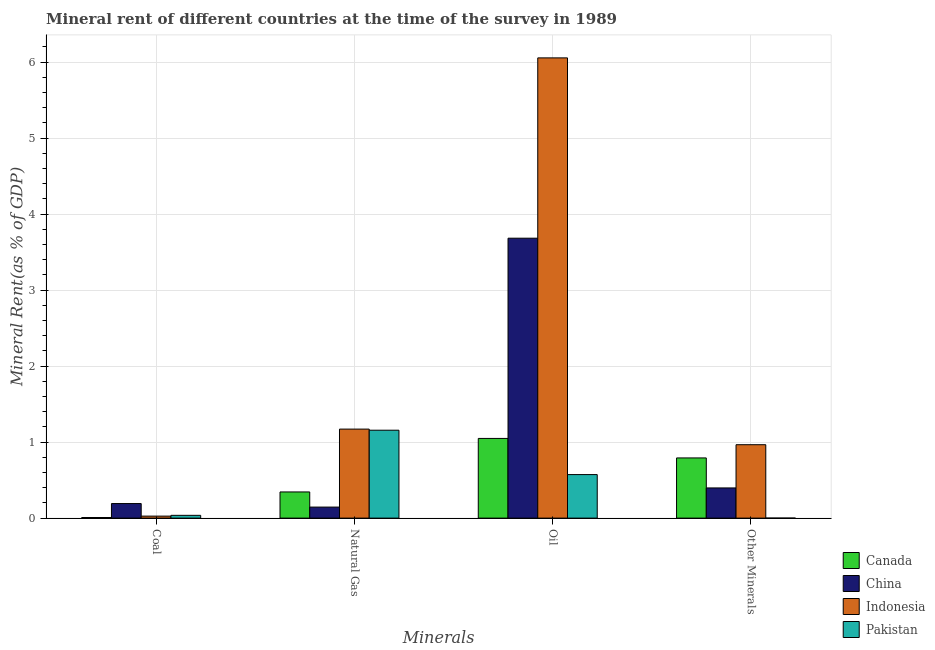How many different coloured bars are there?
Offer a very short reply. 4. Are the number of bars per tick equal to the number of legend labels?
Provide a short and direct response. Yes. Are the number of bars on each tick of the X-axis equal?
Offer a very short reply. Yes. How many bars are there on the 3rd tick from the right?
Offer a very short reply. 4. What is the label of the 3rd group of bars from the left?
Offer a very short reply. Oil. What is the  rent of other minerals in Canada?
Ensure brevity in your answer.  0.79. Across all countries, what is the maximum natural gas rent?
Your answer should be compact. 1.17. Across all countries, what is the minimum  rent of other minerals?
Your response must be concise. 0. In which country was the oil rent maximum?
Your response must be concise. Indonesia. What is the total  rent of other minerals in the graph?
Your response must be concise. 2.16. What is the difference between the natural gas rent in Indonesia and that in China?
Offer a terse response. 1.03. What is the difference between the oil rent in Pakistan and the coal rent in China?
Give a very brief answer. 0.38. What is the average natural gas rent per country?
Your answer should be compact. 0.7. What is the difference between the oil rent and coal rent in Canada?
Give a very brief answer. 1.04. What is the ratio of the coal rent in Indonesia to that in Pakistan?
Provide a short and direct response. 0.72. Is the difference between the coal rent in Pakistan and Indonesia greater than the difference between the  rent of other minerals in Pakistan and Indonesia?
Offer a terse response. Yes. What is the difference between the highest and the second highest oil rent?
Offer a very short reply. 2.37. What is the difference between the highest and the lowest coal rent?
Offer a terse response. 0.18. In how many countries, is the  rent of other minerals greater than the average  rent of other minerals taken over all countries?
Give a very brief answer. 2. Is the sum of the  rent of other minerals in Pakistan and Canada greater than the maximum natural gas rent across all countries?
Make the answer very short. No. Is it the case that in every country, the sum of the oil rent and coal rent is greater than the sum of natural gas rent and  rent of other minerals?
Give a very brief answer. No. What does the 1st bar from the left in Natural Gas represents?
Your answer should be compact. Canada. Is it the case that in every country, the sum of the coal rent and natural gas rent is greater than the oil rent?
Offer a very short reply. No. How many countries are there in the graph?
Offer a very short reply. 4. What is the difference between two consecutive major ticks on the Y-axis?
Offer a very short reply. 1. What is the title of the graph?
Provide a short and direct response. Mineral rent of different countries at the time of the survey in 1989. What is the label or title of the X-axis?
Your answer should be compact. Minerals. What is the label or title of the Y-axis?
Your answer should be very brief. Mineral Rent(as % of GDP). What is the Mineral Rent(as % of GDP) of Canada in Coal?
Your answer should be compact. 0.01. What is the Mineral Rent(as % of GDP) of China in Coal?
Make the answer very short. 0.19. What is the Mineral Rent(as % of GDP) in Indonesia in Coal?
Provide a succinct answer. 0.03. What is the Mineral Rent(as % of GDP) of Pakistan in Coal?
Offer a very short reply. 0.04. What is the Mineral Rent(as % of GDP) of Canada in Natural Gas?
Offer a very short reply. 0.34. What is the Mineral Rent(as % of GDP) in China in Natural Gas?
Keep it short and to the point. 0.15. What is the Mineral Rent(as % of GDP) in Indonesia in Natural Gas?
Ensure brevity in your answer.  1.17. What is the Mineral Rent(as % of GDP) of Pakistan in Natural Gas?
Your response must be concise. 1.16. What is the Mineral Rent(as % of GDP) in Canada in Oil?
Give a very brief answer. 1.05. What is the Mineral Rent(as % of GDP) in China in Oil?
Ensure brevity in your answer.  3.68. What is the Mineral Rent(as % of GDP) in Indonesia in Oil?
Your answer should be compact. 6.06. What is the Mineral Rent(as % of GDP) in Pakistan in Oil?
Keep it short and to the point. 0.57. What is the Mineral Rent(as % of GDP) of Canada in Other Minerals?
Provide a short and direct response. 0.79. What is the Mineral Rent(as % of GDP) of China in Other Minerals?
Give a very brief answer. 0.4. What is the Mineral Rent(as % of GDP) in Indonesia in Other Minerals?
Offer a terse response. 0.97. What is the Mineral Rent(as % of GDP) of Pakistan in Other Minerals?
Offer a very short reply. 0. Across all Minerals, what is the maximum Mineral Rent(as % of GDP) in Canada?
Keep it short and to the point. 1.05. Across all Minerals, what is the maximum Mineral Rent(as % of GDP) of China?
Keep it short and to the point. 3.68. Across all Minerals, what is the maximum Mineral Rent(as % of GDP) in Indonesia?
Make the answer very short. 6.06. Across all Minerals, what is the maximum Mineral Rent(as % of GDP) in Pakistan?
Your answer should be very brief. 1.16. Across all Minerals, what is the minimum Mineral Rent(as % of GDP) in Canada?
Ensure brevity in your answer.  0.01. Across all Minerals, what is the minimum Mineral Rent(as % of GDP) of China?
Provide a succinct answer. 0.15. Across all Minerals, what is the minimum Mineral Rent(as % of GDP) in Indonesia?
Provide a short and direct response. 0.03. Across all Minerals, what is the minimum Mineral Rent(as % of GDP) of Pakistan?
Ensure brevity in your answer.  0. What is the total Mineral Rent(as % of GDP) of Canada in the graph?
Provide a succinct answer. 2.19. What is the total Mineral Rent(as % of GDP) in China in the graph?
Offer a terse response. 4.42. What is the total Mineral Rent(as % of GDP) of Indonesia in the graph?
Your response must be concise. 8.22. What is the total Mineral Rent(as % of GDP) of Pakistan in the graph?
Keep it short and to the point. 1.77. What is the difference between the Mineral Rent(as % of GDP) of Canada in Coal and that in Natural Gas?
Provide a succinct answer. -0.34. What is the difference between the Mineral Rent(as % of GDP) of China in Coal and that in Natural Gas?
Your response must be concise. 0.05. What is the difference between the Mineral Rent(as % of GDP) of Indonesia in Coal and that in Natural Gas?
Give a very brief answer. -1.14. What is the difference between the Mineral Rent(as % of GDP) of Pakistan in Coal and that in Natural Gas?
Give a very brief answer. -1.12. What is the difference between the Mineral Rent(as % of GDP) of Canada in Coal and that in Oil?
Ensure brevity in your answer.  -1.04. What is the difference between the Mineral Rent(as % of GDP) of China in Coal and that in Oil?
Your answer should be compact. -3.49. What is the difference between the Mineral Rent(as % of GDP) in Indonesia in Coal and that in Oil?
Offer a terse response. -6.03. What is the difference between the Mineral Rent(as % of GDP) in Pakistan in Coal and that in Oil?
Provide a succinct answer. -0.54. What is the difference between the Mineral Rent(as % of GDP) of Canada in Coal and that in Other Minerals?
Offer a very short reply. -0.78. What is the difference between the Mineral Rent(as % of GDP) of China in Coal and that in Other Minerals?
Offer a terse response. -0.21. What is the difference between the Mineral Rent(as % of GDP) of Indonesia in Coal and that in Other Minerals?
Make the answer very short. -0.94. What is the difference between the Mineral Rent(as % of GDP) in Pakistan in Coal and that in Other Minerals?
Offer a terse response. 0.04. What is the difference between the Mineral Rent(as % of GDP) in Canada in Natural Gas and that in Oil?
Offer a very short reply. -0.7. What is the difference between the Mineral Rent(as % of GDP) of China in Natural Gas and that in Oil?
Your response must be concise. -3.54. What is the difference between the Mineral Rent(as % of GDP) in Indonesia in Natural Gas and that in Oil?
Offer a very short reply. -4.88. What is the difference between the Mineral Rent(as % of GDP) of Pakistan in Natural Gas and that in Oil?
Your answer should be compact. 0.58. What is the difference between the Mineral Rent(as % of GDP) of Canada in Natural Gas and that in Other Minerals?
Offer a very short reply. -0.45. What is the difference between the Mineral Rent(as % of GDP) of China in Natural Gas and that in Other Minerals?
Your answer should be compact. -0.25. What is the difference between the Mineral Rent(as % of GDP) in Indonesia in Natural Gas and that in Other Minerals?
Your answer should be compact. 0.21. What is the difference between the Mineral Rent(as % of GDP) in Pakistan in Natural Gas and that in Other Minerals?
Offer a very short reply. 1.16. What is the difference between the Mineral Rent(as % of GDP) of Canada in Oil and that in Other Minerals?
Provide a short and direct response. 0.26. What is the difference between the Mineral Rent(as % of GDP) of China in Oil and that in Other Minerals?
Your answer should be compact. 3.29. What is the difference between the Mineral Rent(as % of GDP) in Indonesia in Oil and that in Other Minerals?
Provide a short and direct response. 5.09. What is the difference between the Mineral Rent(as % of GDP) in Pakistan in Oil and that in Other Minerals?
Ensure brevity in your answer.  0.57. What is the difference between the Mineral Rent(as % of GDP) of Canada in Coal and the Mineral Rent(as % of GDP) of China in Natural Gas?
Your response must be concise. -0.14. What is the difference between the Mineral Rent(as % of GDP) of Canada in Coal and the Mineral Rent(as % of GDP) of Indonesia in Natural Gas?
Offer a very short reply. -1.16. What is the difference between the Mineral Rent(as % of GDP) in Canada in Coal and the Mineral Rent(as % of GDP) in Pakistan in Natural Gas?
Give a very brief answer. -1.15. What is the difference between the Mineral Rent(as % of GDP) in China in Coal and the Mineral Rent(as % of GDP) in Indonesia in Natural Gas?
Keep it short and to the point. -0.98. What is the difference between the Mineral Rent(as % of GDP) in China in Coal and the Mineral Rent(as % of GDP) in Pakistan in Natural Gas?
Give a very brief answer. -0.96. What is the difference between the Mineral Rent(as % of GDP) of Indonesia in Coal and the Mineral Rent(as % of GDP) of Pakistan in Natural Gas?
Your answer should be compact. -1.13. What is the difference between the Mineral Rent(as % of GDP) of Canada in Coal and the Mineral Rent(as % of GDP) of China in Oil?
Keep it short and to the point. -3.67. What is the difference between the Mineral Rent(as % of GDP) in Canada in Coal and the Mineral Rent(as % of GDP) in Indonesia in Oil?
Provide a succinct answer. -6.05. What is the difference between the Mineral Rent(as % of GDP) of Canada in Coal and the Mineral Rent(as % of GDP) of Pakistan in Oil?
Keep it short and to the point. -0.56. What is the difference between the Mineral Rent(as % of GDP) of China in Coal and the Mineral Rent(as % of GDP) of Indonesia in Oil?
Offer a terse response. -5.86. What is the difference between the Mineral Rent(as % of GDP) of China in Coal and the Mineral Rent(as % of GDP) of Pakistan in Oil?
Your response must be concise. -0.38. What is the difference between the Mineral Rent(as % of GDP) in Indonesia in Coal and the Mineral Rent(as % of GDP) in Pakistan in Oil?
Provide a succinct answer. -0.55. What is the difference between the Mineral Rent(as % of GDP) in Canada in Coal and the Mineral Rent(as % of GDP) in China in Other Minerals?
Provide a succinct answer. -0.39. What is the difference between the Mineral Rent(as % of GDP) of Canada in Coal and the Mineral Rent(as % of GDP) of Indonesia in Other Minerals?
Offer a terse response. -0.96. What is the difference between the Mineral Rent(as % of GDP) of Canada in Coal and the Mineral Rent(as % of GDP) of Pakistan in Other Minerals?
Offer a very short reply. 0.01. What is the difference between the Mineral Rent(as % of GDP) of China in Coal and the Mineral Rent(as % of GDP) of Indonesia in Other Minerals?
Offer a terse response. -0.77. What is the difference between the Mineral Rent(as % of GDP) in China in Coal and the Mineral Rent(as % of GDP) in Pakistan in Other Minerals?
Give a very brief answer. 0.19. What is the difference between the Mineral Rent(as % of GDP) of Indonesia in Coal and the Mineral Rent(as % of GDP) of Pakistan in Other Minerals?
Provide a short and direct response. 0.03. What is the difference between the Mineral Rent(as % of GDP) in Canada in Natural Gas and the Mineral Rent(as % of GDP) in China in Oil?
Provide a succinct answer. -3.34. What is the difference between the Mineral Rent(as % of GDP) of Canada in Natural Gas and the Mineral Rent(as % of GDP) of Indonesia in Oil?
Give a very brief answer. -5.71. What is the difference between the Mineral Rent(as % of GDP) in Canada in Natural Gas and the Mineral Rent(as % of GDP) in Pakistan in Oil?
Offer a terse response. -0.23. What is the difference between the Mineral Rent(as % of GDP) of China in Natural Gas and the Mineral Rent(as % of GDP) of Indonesia in Oil?
Offer a very short reply. -5.91. What is the difference between the Mineral Rent(as % of GDP) of China in Natural Gas and the Mineral Rent(as % of GDP) of Pakistan in Oil?
Ensure brevity in your answer.  -0.43. What is the difference between the Mineral Rent(as % of GDP) of Indonesia in Natural Gas and the Mineral Rent(as % of GDP) of Pakistan in Oil?
Make the answer very short. 0.6. What is the difference between the Mineral Rent(as % of GDP) in Canada in Natural Gas and the Mineral Rent(as % of GDP) in China in Other Minerals?
Make the answer very short. -0.05. What is the difference between the Mineral Rent(as % of GDP) of Canada in Natural Gas and the Mineral Rent(as % of GDP) of Indonesia in Other Minerals?
Make the answer very short. -0.62. What is the difference between the Mineral Rent(as % of GDP) of Canada in Natural Gas and the Mineral Rent(as % of GDP) of Pakistan in Other Minerals?
Make the answer very short. 0.34. What is the difference between the Mineral Rent(as % of GDP) of China in Natural Gas and the Mineral Rent(as % of GDP) of Indonesia in Other Minerals?
Give a very brief answer. -0.82. What is the difference between the Mineral Rent(as % of GDP) in China in Natural Gas and the Mineral Rent(as % of GDP) in Pakistan in Other Minerals?
Provide a short and direct response. 0.14. What is the difference between the Mineral Rent(as % of GDP) of Indonesia in Natural Gas and the Mineral Rent(as % of GDP) of Pakistan in Other Minerals?
Ensure brevity in your answer.  1.17. What is the difference between the Mineral Rent(as % of GDP) in Canada in Oil and the Mineral Rent(as % of GDP) in China in Other Minerals?
Ensure brevity in your answer.  0.65. What is the difference between the Mineral Rent(as % of GDP) of Canada in Oil and the Mineral Rent(as % of GDP) of Indonesia in Other Minerals?
Give a very brief answer. 0.08. What is the difference between the Mineral Rent(as % of GDP) in Canada in Oil and the Mineral Rent(as % of GDP) in Pakistan in Other Minerals?
Provide a short and direct response. 1.05. What is the difference between the Mineral Rent(as % of GDP) in China in Oil and the Mineral Rent(as % of GDP) in Indonesia in Other Minerals?
Give a very brief answer. 2.72. What is the difference between the Mineral Rent(as % of GDP) in China in Oil and the Mineral Rent(as % of GDP) in Pakistan in Other Minerals?
Ensure brevity in your answer.  3.68. What is the difference between the Mineral Rent(as % of GDP) in Indonesia in Oil and the Mineral Rent(as % of GDP) in Pakistan in Other Minerals?
Ensure brevity in your answer.  6.06. What is the average Mineral Rent(as % of GDP) in Canada per Minerals?
Your response must be concise. 0.55. What is the average Mineral Rent(as % of GDP) in China per Minerals?
Ensure brevity in your answer.  1.1. What is the average Mineral Rent(as % of GDP) of Indonesia per Minerals?
Make the answer very short. 2.05. What is the average Mineral Rent(as % of GDP) in Pakistan per Minerals?
Offer a terse response. 0.44. What is the difference between the Mineral Rent(as % of GDP) of Canada and Mineral Rent(as % of GDP) of China in Coal?
Your answer should be compact. -0.18. What is the difference between the Mineral Rent(as % of GDP) of Canada and Mineral Rent(as % of GDP) of Indonesia in Coal?
Keep it short and to the point. -0.02. What is the difference between the Mineral Rent(as % of GDP) in Canada and Mineral Rent(as % of GDP) in Pakistan in Coal?
Provide a succinct answer. -0.03. What is the difference between the Mineral Rent(as % of GDP) of China and Mineral Rent(as % of GDP) of Indonesia in Coal?
Offer a very short reply. 0.17. What is the difference between the Mineral Rent(as % of GDP) in China and Mineral Rent(as % of GDP) in Pakistan in Coal?
Provide a short and direct response. 0.15. What is the difference between the Mineral Rent(as % of GDP) in Indonesia and Mineral Rent(as % of GDP) in Pakistan in Coal?
Your answer should be very brief. -0.01. What is the difference between the Mineral Rent(as % of GDP) of Canada and Mineral Rent(as % of GDP) of China in Natural Gas?
Your answer should be very brief. 0.2. What is the difference between the Mineral Rent(as % of GDP) of Canada and Mineral Rent(as % of GDP) of Indonesia in Natural Gas?
Provide a succinct answer. -0.83. What is the difference between the Mineral Rent(as % of GDP) of Canada and Mineral Rent(as % of GDP) of Pakistan in Natural Gas?
Give a very brief answer. -0.81. What is the difference between the Mineral Rent(as % of GDP) in China and Mineral Rent(as % of GDP) in Indonesia in Natural Gas?
Give a very brief answer. -1.03. What is the difference between the Mineral Rent(as % of GDP) of China and Mineral Rent(as % of GDP) of Pakistan in Natural Gas?
Offer a terse response. -1.01. What is the difference between the Mineral Rent(as % of GDP) of Indonesia and Mineral Rent(as % of GDP) of Pakistan in Natural Gas?
Provide a short and direct response. 0.01. What is the difference between the Mineral Rent(as % of GDP) of Canada and Mineral Rent(as % of GDP) of China in Oil?
Offer a terse response. -2.63. What is the difference between the Mineral Rent(as % of GDP) of Canada and Mineral Rent(as % of GDP) of Indonesia in Oil?
Provide a short and direct response. -5.01. What is the difference between the Mineral Rent(as % of GDP) of Canada and Mineral Rent(as % of GDP) of Pakistan in Oil?
Give a very brief answer. 0.48. What is the difference between the Mineral Rent(as % of GDP) of China and Mineral Rent(as % of GDP) of Indonesia in Oil?
Your answer should be compact. -2.37. What is the difference between the Mineral Rent(as % of GDP) in China and Mineral Rent(as % of GDP) in Pakistan in Oil?
Your response must be concise. 3.11. What is the difference between the Mineral Rent(as % of GDP) in Indonesia and Mineral Rent(as % of GDP) in Pakistan in Oil?
Give a very brief answer. 5.48. What is the difference between the Mineral Rent(as % of GDP) of Canada and Mineral Rent(as % of GDP) of China in Other Minerals?
Make the answer very short. 0.39. What is the difference between the Mineral Rent(as % of GDP) of Canada and Mineral Rent(as % of GDP) of Indonesia in Other Minerals?
Provide a short and direct response. -0.17. What is the difference between the Mineral Rent(as % of GDP) of Canada and Mineral Rent(as % of GDP) of Pakistan in Other Minerals?
Your answer should be very brief. 0.79. What is the difference between the Mineral Rent(as % of GDP) in China and Mineral Rent(as % of GDP) in Indonesia in Other Minerals?
Your answer should be compact. -0.57. What is the difference between the Mineral Rent(as % of GDP) in China and Mineral Rent(as % of GDP) in Pakistan in Other Minerals?
Make the answer very short. 0.4. What is the difference between the Mineral Rent(as % of GDP) of Indonesia and Mineral Rent(as % of GDP) of Pakistan in Other Minerals?
Your response must be concise. 0.97. What is the ratio of the Mineral Rent(as % of GDP) of Canada in Coal to that in Natural Gas?
Offer a terse response. 0.02. What is the ratio of the Mineral Rent(as % of GDP) of China in Coal to that in Natural Gas?
Provide a short and direct response. 1.32. What is the ratio of the Mineral Rent(as % of GDP) in Indonesia in Coal to that in Natural Gas?
Keep it short and to the point. 0.02. What is the ratio of the Mineral Rent(as % of GDP) in Pakistan in Coal to that in Natural Gas?
Your response must be concise. 0.03. What is the ratio of the Mineral Rent(as % of GDP) of Canada in Coal to that in Oil?
Your answer should be compact. 0.01. What is the ratio of the Mineral Rent(as % of GDP) in China in Coal to that in Oil?
Offer a terse response. 0.05. What is the ratio of the Mineral Rent(as % of GDP) in Indonesia in Coal to that in Oil?
Keep it short and to the point. 0. What is the ratio of the Mineral Rent(as % of GDP) in Pakistan in Coal to that in Oil?
Your answer should be very brief. 0.06. What is the ratio of the Mineral Rent(as % of GDP) of Canada in Coal to that in Other Minerals?
Give a very brief answer. 0.01. What is the ratio of the Mineral Rent(as % of GDP) in China in Coal to that in Other Minerals?
Provide a short and direct response. 0.48. What is the ratio of the Mineral Rent(as % of GDP) in Indonesia in Coal to that in Other Minerals?
Keep it short and to the point. 0.03. What is the ratio of the Mineral Rent(as % of GDP) of Pakistan in Coal to that in Other Minerals?
Make the answer very short. 282.01. What is the ratio of the Mineral Rent(as % of GDP) of Canada in Natural Gas to that in Oil?
Give a very brief answer. 0.33. What is the ratio of the Mineral Rent(as % of GDP) in China in Natural Gas to that in Oil?
Ensure brevity in your answer.  0.04. What is the ratio of the Mineral Rent(as % of GDP) in Indonesia in Natural Gas to that in Oil?
Provide a succinct answer. 0.19. What is the ratio of the Mineral Rent(as % of GDP) of Pakistan in Natural Gas to that in Oil?
Offer a very short reply. 2.02. What is the ratio of the Mineral Rent(as % of GDP) of Canada in Natural Gas to that in Other Minerals?
Your response must be concise. 0.43. What is the ratio of the Mineral Rent(as % of GDP) in China in Natural Gas to that in Other Minerals?
Make the answer very short. 0.37. What is the ratio of the Mineral Rent(as % of GDP) in Indonesia in Natural Gas to that in Other Minerals?
Offer a terse response. 1.21. What is the ratio of the Mineral Rent(as % of GDP) of Pakistan in Natural Gas to that in Other Minerals?
Give a very brief answer. 8900.49. What is the ratio of the Mineral Rent(as % of GDP) of Canada in Oil to that in Other Minerals?
Your answer should be very brief. 1.32. What is the ratio of the Mineral Rent(as % of GDP) in China in Oil to that in Other Minerals?
Offer a very short reply. 9.27. What is the ratio of the Mineral Rent(as % of GDP) in Indonesia in Oil to that in Other Minerals?
Your response must be concise. 6.27. What is the ratio of the Mineral Rent(as % of GDP) of Pakistan in Oil to that in Other Minerals?
Ensure brevity in your answer.  4408.16. What is the difference between the highest and the second highest Mineral Rent(as % of GDP) in Canada?
Ensure brevity in your answer.  0.26. What is the difference between the highest and the second highest Mineral Rent(as % of GDP) of China?
Offer a very short reply. 3.29. What is the difference between the highest and the second highest Mineral Rent(as % of GDP) of Indonesia?
Provide a succinct answer. 4.88. What is the difference between the highest and the second highest Mineral Rent(as % of GDP) of Pakistan?
Your response must be concise. 0.58. What is the difference between the highest and the lowest Mineral Rent(as % of GDP) in Canada?
Your response must be concise. 1.04. What is the difference between the highest and the lowest Mineral Rent(as % of GDP) of China?
Your response must be concise. 3.54. What is the difference between the highest and the lowest Mineral Rent(as % of GDP) of Indonesia?
Your response must be concise. 6.03. What is the difference between the highest and the lowest Mineral Rent(as % of GDP) of Pakistan?
Your response must be concise. 1.16. 